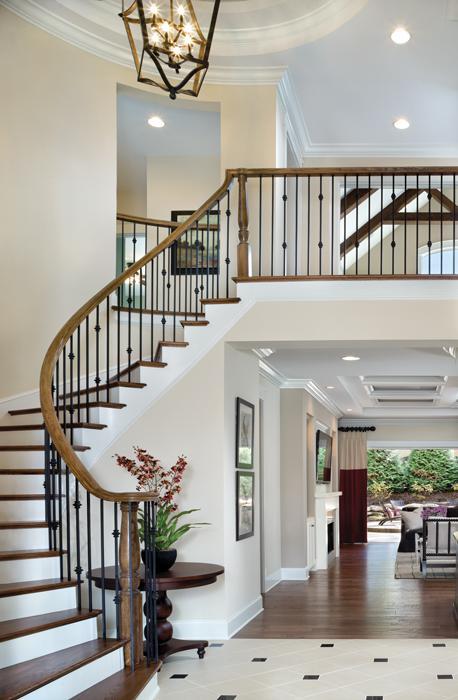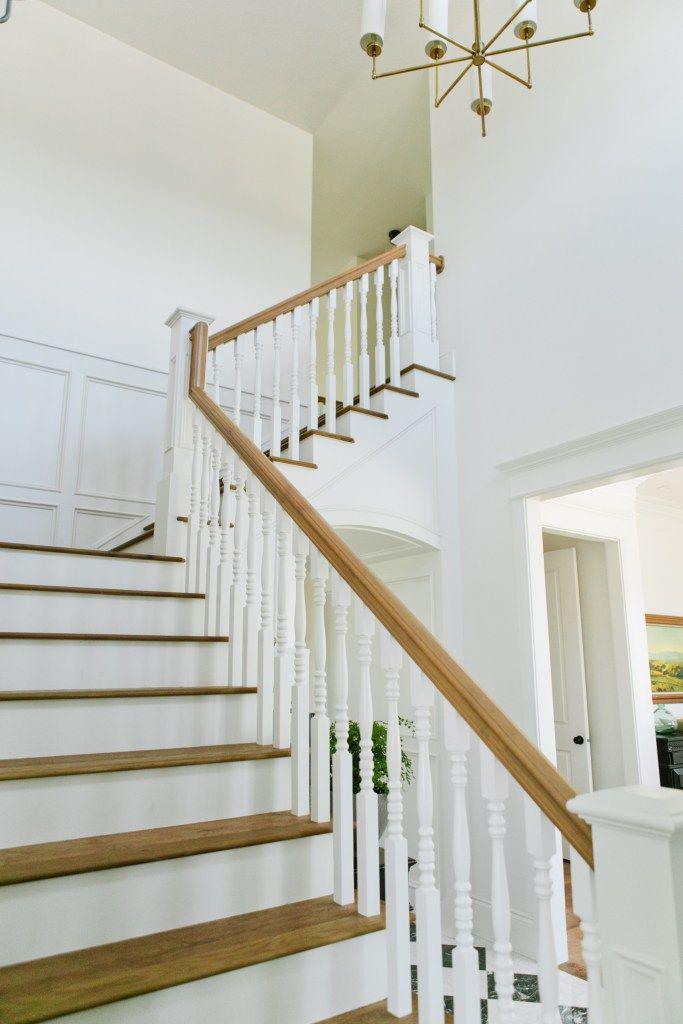The first image is the image on the left, the second image is the image on the right. Evaluate the accuracy of this statement regarding the images: "The left image features a curving staircase with a wooden handrail and vertical wrought iron bars with a dimensional decorative element.". Is it true? Answer yes or no. Yes. The first image is the image on the left, the second image is the image on the right. Evaluate the accuracy of this statement regarding the images: "In at least one image there are brown railed stair that curve as they come down to the floor.". Is it true? Answer yes or no. Yes. 